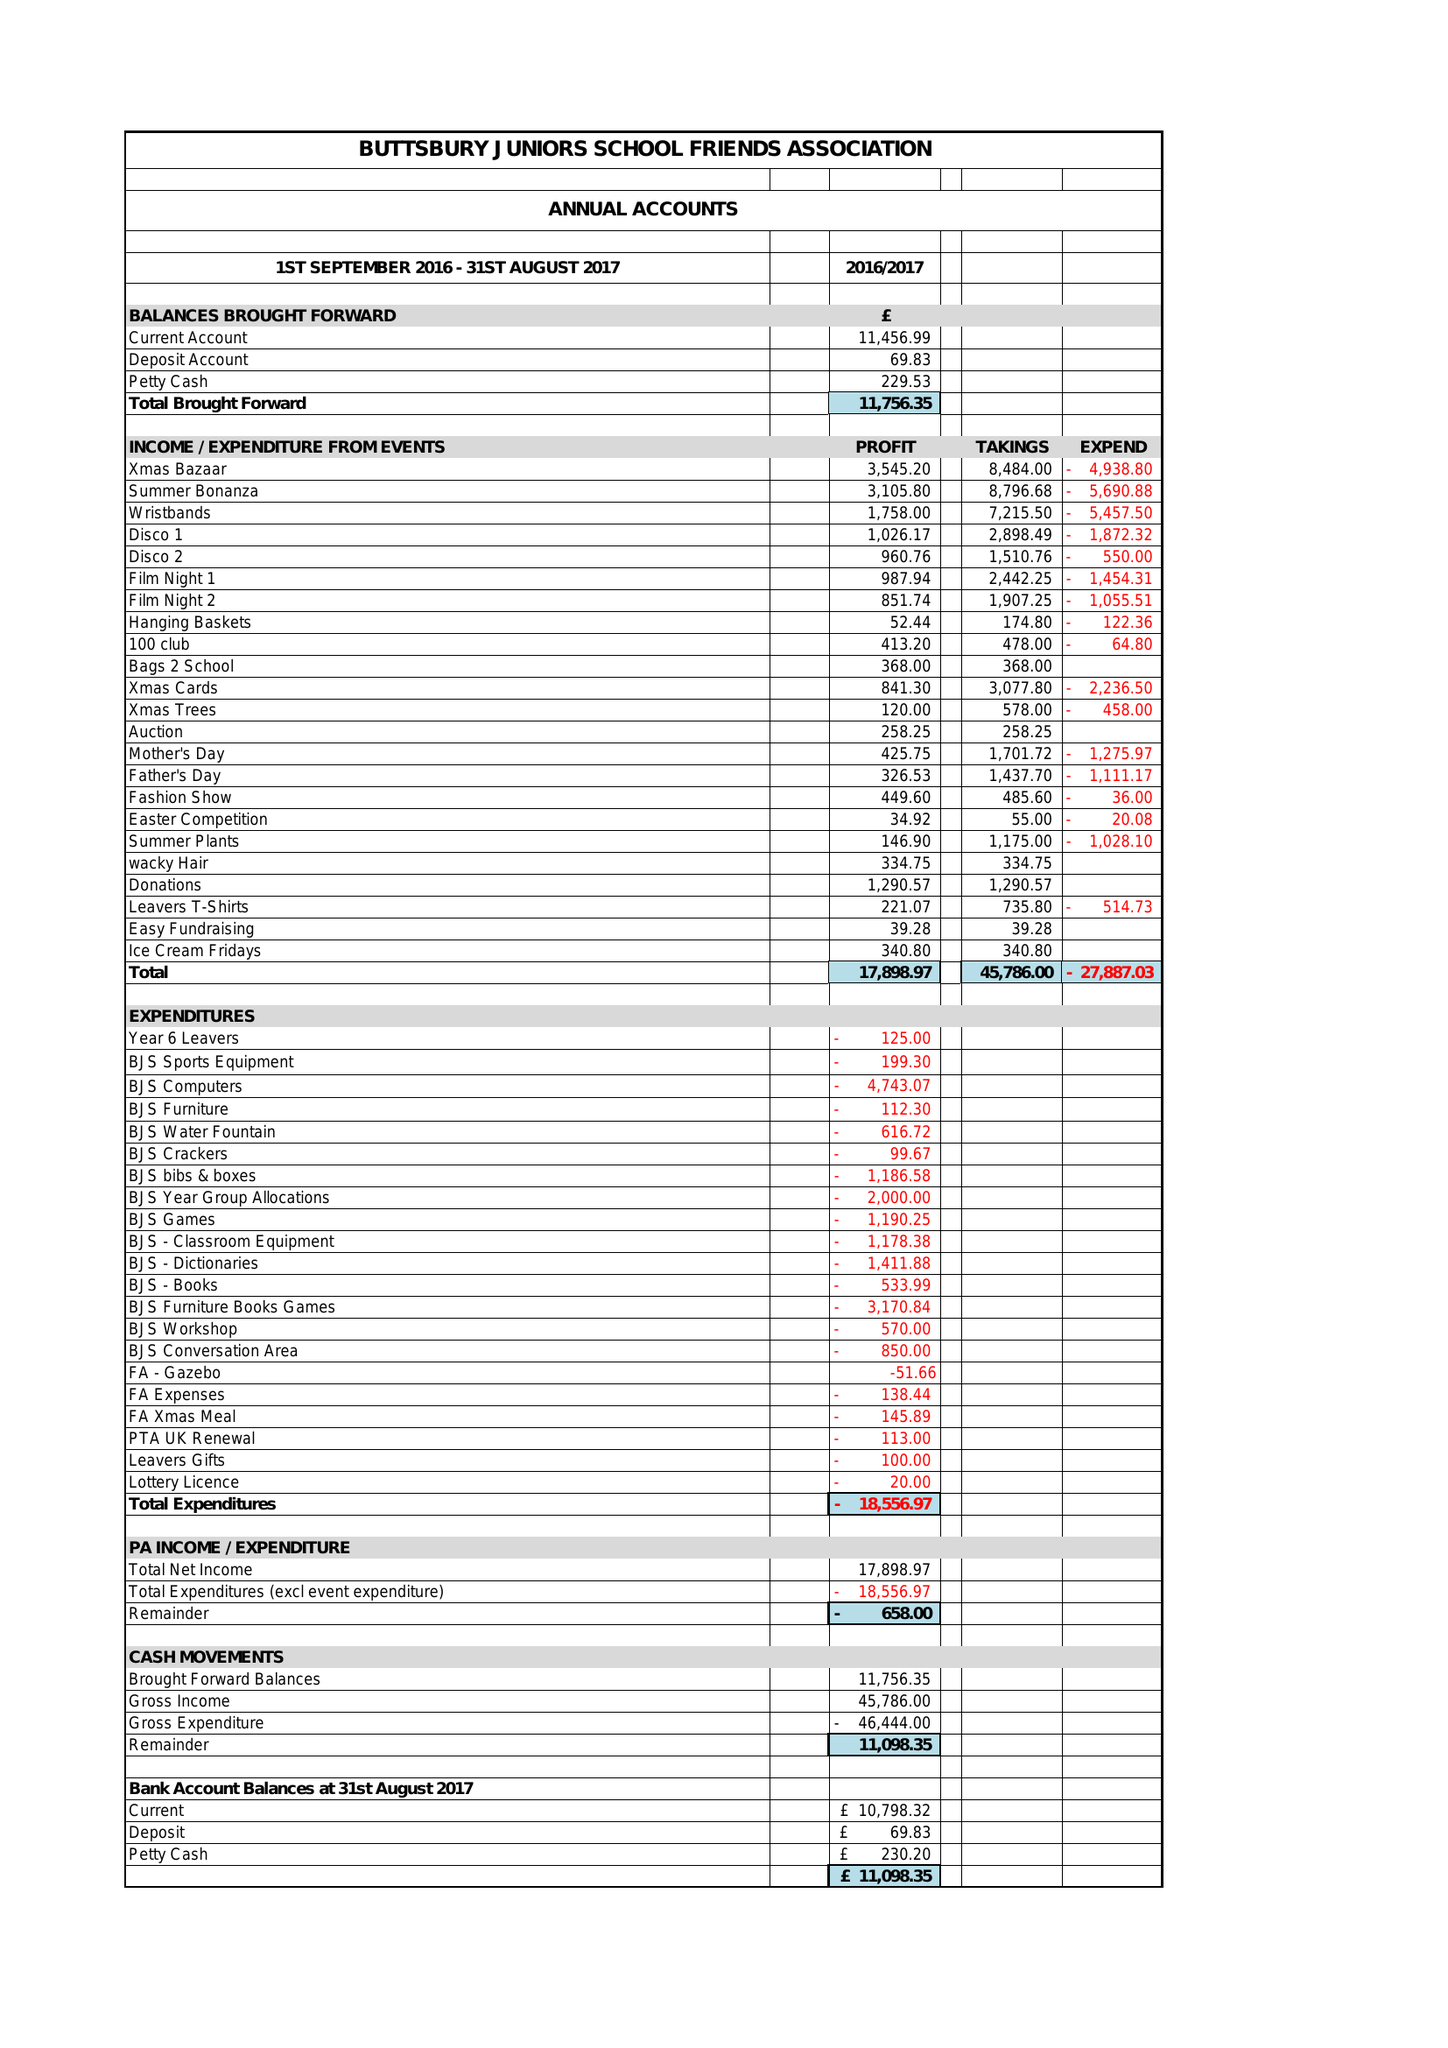What is the value for the report_date?
Answer the question using a single word or phrase. 2017-07-31 